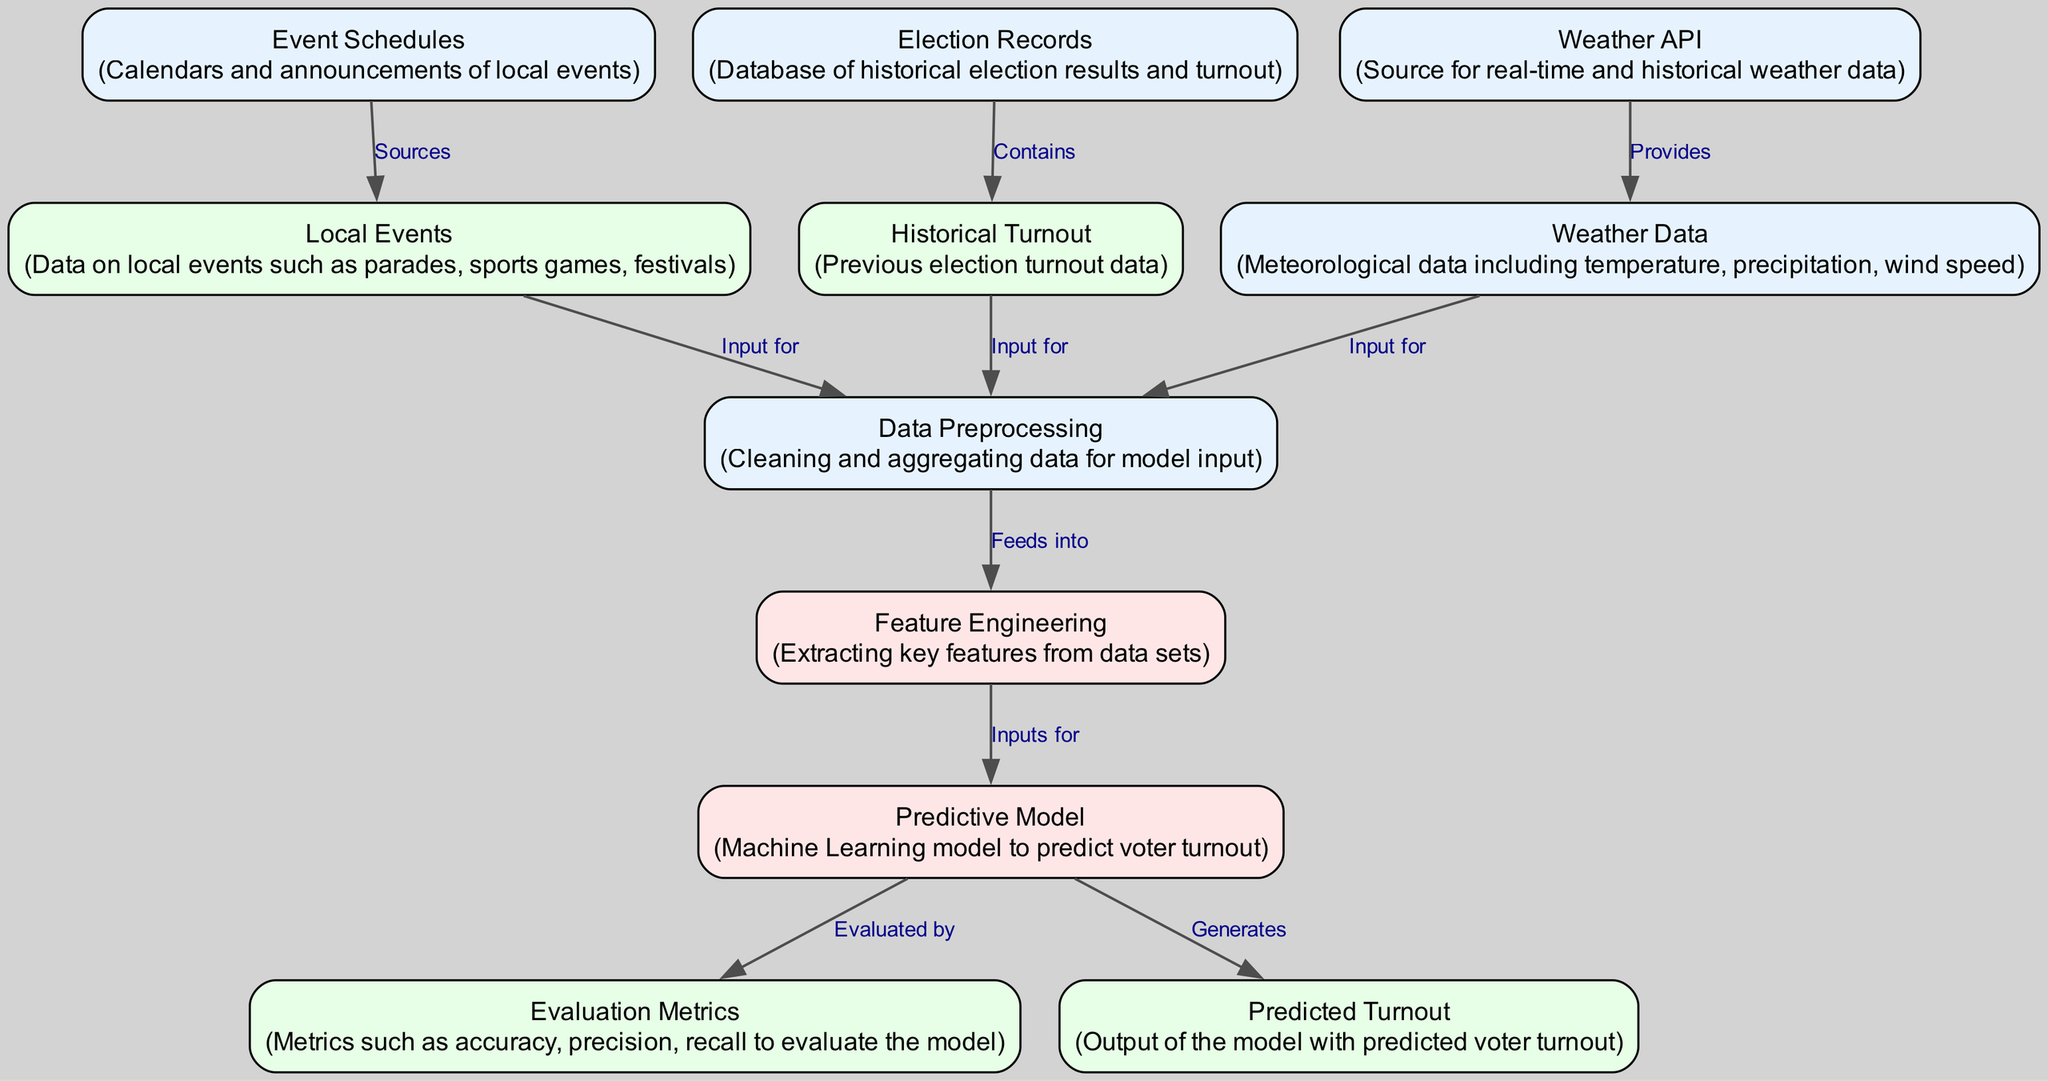What nodes are involved in data preprocessing? The nodes that contribute to data preprocessing are Weather Data, Local Events, and Historical Turnout. Each of these nodes feeds into the Data Preprocessing node, which collects and prepares the data for further processing.
Answer: Weather Data, Local Events, Historical Turnout What type of data is provided by the Weather API? The Weather API provides real-time and historical weather data, which is essential for predicting voter turnout based on weather conditions.
Answer: Real-time and historical weather data How many edges are there in the diagram? By counting each connection between nodes, we find there are 10 edges present in the diagram which represent the flow of data and relationships between the nodes.
Answer: 10 What is the output generated by the Predictive Model? The output generated by the Predictive Model is the predicted voter turnout, which indicates the estimated number of people likely to vote based on the input data.
Answer: Predicted voter turnout Which nodes are responsible for input to the Feature Engineering node? The nodes providing input to the Feature Engineering node are Data Preprocessing, acknowledging that it aggregates and prepares the data prior to feature extraction.
Answer: Data Preprocessing What type of metrics are used for evaluation in the model? The Evaluation Metrics node incorporates metrics such as accuracy, precision, and recall to assess the performance of the predictive model accurately.
Answer: Accuracy, precision, recall Which node contains historical election results? The Election Records node specifically contains the historical election results and turnout data, which are crucial for analyzing trends in voter participation over time.
Answer: Election Records What two types of data do Local Events provide? The Local Events node provides data on local parades, sports games, and festivals, which can impact voter turnout by either diverting attention or engaging the community.
Answer: Parades, sports games, festivals How does the Weather Data node influence Data Preprocessing? The Weather Data node influences Data Preprocessing by providing crucial meteorological conditions such as temperature, precipitation, and wind speed, which are essential parameters for predicting turnout.
Answer: Meteorological conditions 